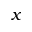Convert formula to latex. <formula><loc_0><loc_0><loc_500><loc_500>x</formula> 